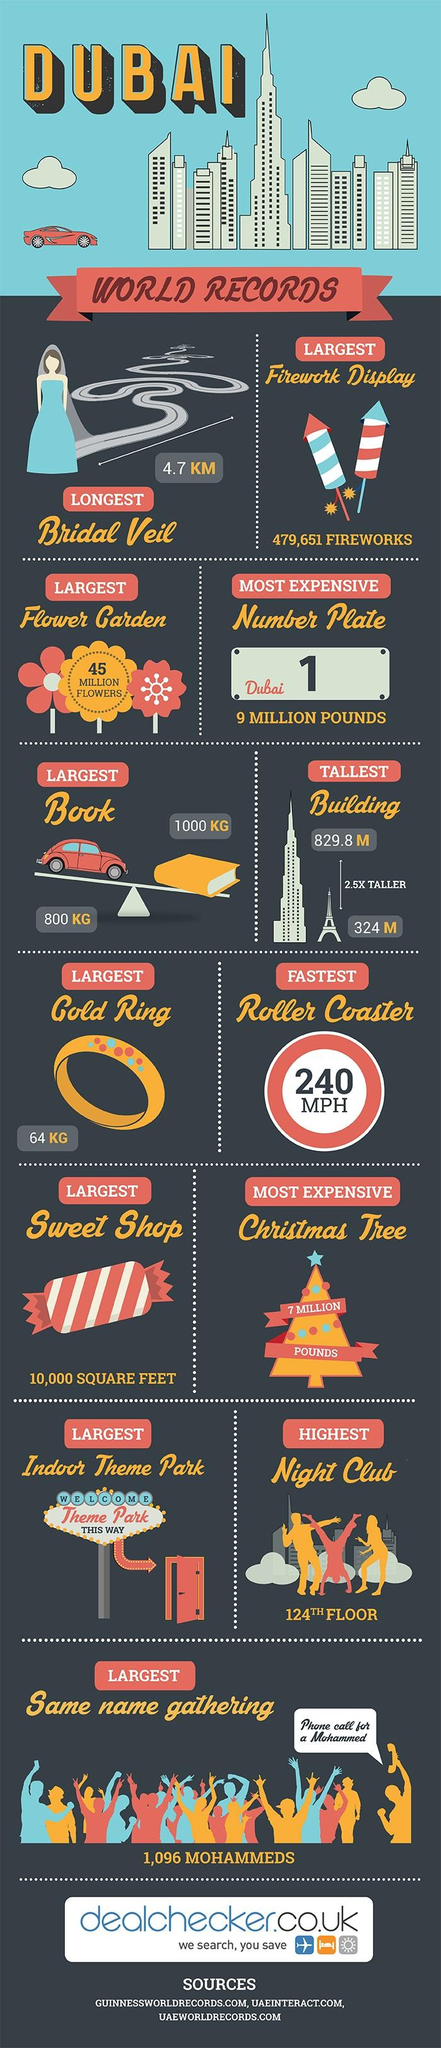Give some essential details in this illustration. The speaker inquired about the name of the person who gathered everyone together, and the name given was Mohammed. The number plate on the vehicle reads 'Dubai 1...'. The sign board displays the words 'Welcome' followed by the name of the Theme Park, with an exclamatory point and the phrase 'This Way.' The dress of the bride is blue, and it is the color of the dress of the bride. The cost of Number Plate Dubai 1 was approximately 9 million pounds. 